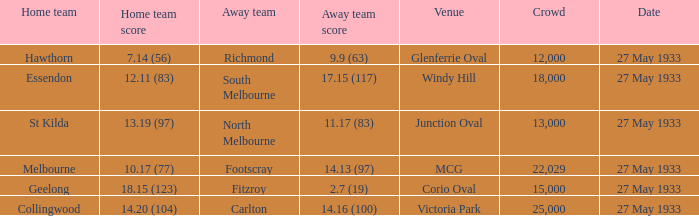In the match where the away team scored 2.7 (19), how many peopel were in the crowd? 15000.0. 